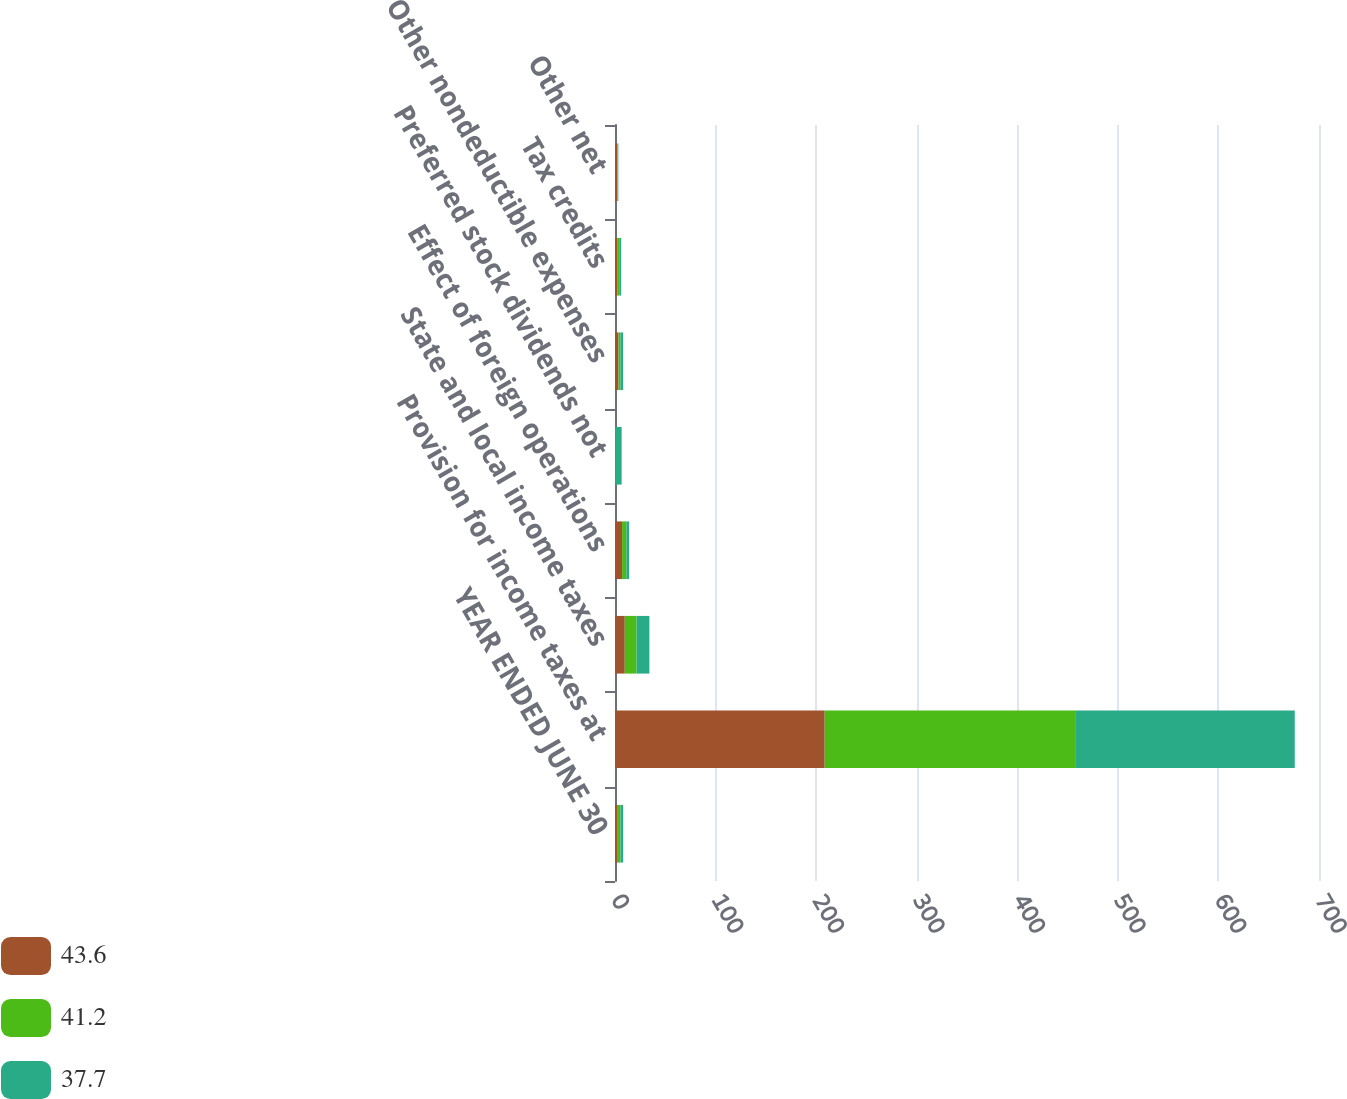Convert chart to OTSL. <chart><loc_0><loc_0><loc_500><loc_500><stacked_bar_chart><ecel><fcel>YEAR ENDED JUNE 30<fcel>Provision for income taxes at<fcel>State and local income taxes<fcel>Effect of foreign operations<fcel>Preferred stock dividends not<fcel>Other nondeductible expenses<fcel>Tax credits<fcel>Other net<nl><fcel>43.6<fcel>2.7<fcel>208.5<fcel>9.7<fcel>7<fcel>0.2<fcel>3.4<fcel>2.2<fcel>2<nl><fcel>41.2<fcel>2.7<fcel>249.8<fcel>11.8<fcel>4.3<fcel>0.3<fcel>2<fcel>2.6<fcel>0.6<nl><fcel>37.7<fcel>2.7<fcel>217.6<fcel>12.7<fcel>2.7<fcel>6.1<fcel>2.7<fcel>1.3<fcel>0.7<nl></chart> 